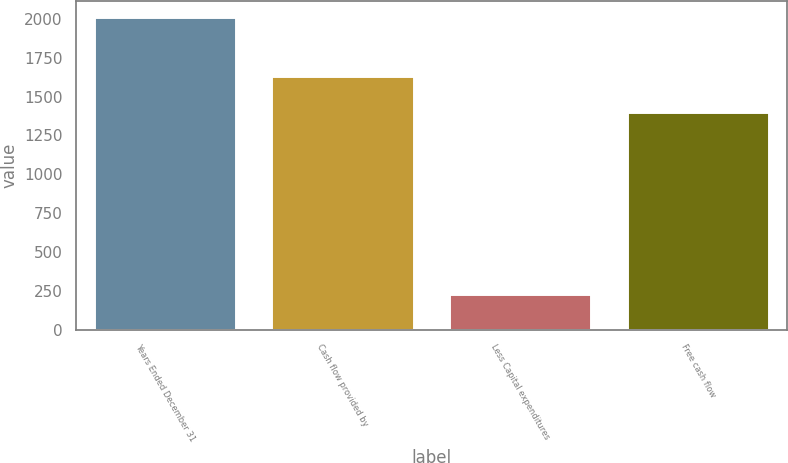<chart> <loc_0><loc_0><loc_500><loc_500><bar_chart><fcel>Years Ended December 31<fcel>Cash flow provided by<fcel>Less Capital expenditures<fcel>Free cash flow<nl><fcel>2013<fcel>1633<fcel>229<fcel>1404<nl></chart> 